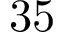<formula> <loc_0><loc_0><loc_500><loc_500>3 5</formula> 